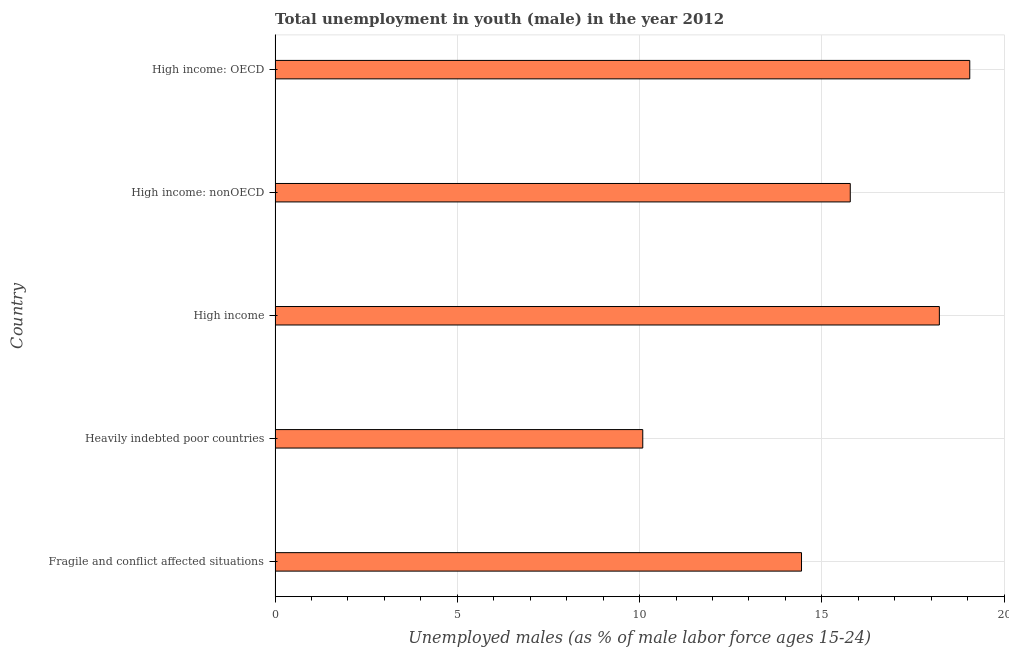Does the graph contain any zero values?
Keep it short and to the point. No. Does the graph contain grids?
Make the answer very short. Yes. What is the title of the graph?
Your answer should be compact. Total unemployment in youth (male) in the year 2012. What is the label or title of the X-axis?
Provide a short and direct response. Unemployed males (as % of male labor force ages 15-24). What is the unemployed male youth population in High income?
Give a very brief answer. 18.23. Across all countries, what is the maximum unemployed male youth population?
Provide a short and direct response. 19.06. Across all countries, what is the minimum unemployed male youth population?
Make the answer very short. 10.09. In which country was the unemployed male youth population maximum?
Give a very brief answer. High income: OECD. In which country was the unemployed male youth population minimum?
Offer a very short reply. Heavily indebted poor countries. What is the sum of the unemployed male youth population?
Provide a succinct answer. 77.6. What is the difference between the unemployed male youth population in Fragile and conflict affected situations and Heavily indebted poor countries?
Give a very brief answer. 4.36. What is the average unemployed male youth population per country?
Give a very brief answer. 15.52. What is the median unemployed male youth population?
Keep it short and to the point. 15.78. In how many countries, is the unemployed male youth population greater than 14 %?
Your answer should be compact. 4. What is the ratio of the unemployed male youth population in High income to that in High income: OECD?
Your answer should be compact. 0.96. Is the unemployed male youth population in High income: OECD less than that in High income: nonOECD?
Provide a short and direct response. No. What is the difference between the highest and the second highest unemployed male youth population?
Give a very brief answer. 0.83. What is the difference between the highest and the lowest unemployed male youth population?
Your response must be concise. 8.97. Are the values on the major ticks of X-axis written in scientific E-notation?
Offer a very short reply. No. What is the Unemployed males (as % of male labor force ages 15-24) in Fragile and conflict affected situations?
Provide a short and direct response. 14.44. What is the Unemployed males (as % of male labor force ages 15-24) of Heavily indebted poor countries?
Your answer should be compact. 10.09. What is the Unemployed males (as % of male labor force ages 15-24) in High income?
Ensure brevity in your answer.  18.23. What is the Unemployed males (as % of male labor force ages 15-24) of High income: nonOECD?
Ensure brevity in your answer.  15.78. What is the Unemployed males (as % of male labor force ages 15-24) of High income: OECD?
Offer a terse response. 19.06. What is the difference between the Unemployed males (as % of male labor force ages 15-24) in Fragile and conflict affected situations and Heavily indebted poor countries?
Offer a very short reply. 4.36. What is the difference between the Unemployed males (as % of male labor force ages 15-24) in Fragile and conflict affected situations and High income?
Your response must be concise. -3.78. What is the difference between the Unemployed males (as % of male labor force ages 15-24) in Fragile and conflict affected situations and High income: nonOECD?
Your answer should be very brief. -1.34. What is the difference between the Unemployed males (as % of male labor force ages 15-24) in Fragile and conflict affected situations and High income: OECD?
Your answer should be very brief. -4.62. What is the difference between the Unemployed males (as % of male labor force ages 15-24) in Heavily indebted poor countries and High income?
Your answer should be very brief. -8.14. What is the difference between the Unemployed males (as % of male labor force ages 15-24) in Heavily indebted poor countries and High income: nonOECD?
Give a very brief answer. -5.69. What is the difference between the Unemployed males (as % of male labor force ages 15-24) in Heavily indebted poor countries and High income: OECD?
Your answer should be compact. -8.97. What is the difference between the Unemployed males (as % of male labor force ages 15-24) in High income and High income: nonOECD?
Provide a short and direct response. 2.44. What is the difference between the Unemployed males (as % of male labor force ages 15-24) in High income and High income: OECD?
Make the answer very short. -0.83. What is the difference between the Unemployed males (as % of male labor force ages 15-24) in High income: nonOECD and High income: OECD?
Offer a very short reply. -3.28. What is the ratio of the Unemployed males (as % of male labor force ages 15-24) in Fragile and conflict affected situations to that in Heavily indebted poor countries?
Your response must be concise. 1.43. What is the ratio of the Unemployed males (as % of male labor force ages 15-24) in Fragile and conflict affected situations to that in High income?
Keep it short and to the point. 0.79. What is the ratio of the Unemployed males (as % of male labor force ages 15-24) in Fragile and conflict affected situations to that in High income: nonOECD?
Offer a very short reply. 0.92. What is the ratio of the Unemployed males (as % of male labor force ages 15-24) in Fragile and conflict affected situations to that in High income: OECD?
Your answer should be compact. 0.76. What is the ratio of the Unemployed males (as % of male labor force ages 15-24) in Heavily indebted poor countries to that in High income?
Keep it short and to the point. 0.55. What is the ratio of the Unemployed males (as % of male labor force ages 15-24) in Heavily indebted poor countries to that in High income: nonOECD?
Your answer should be compact. 0.64. What is the ratio of the Unemployed males (as % of male labor force ages 15-24) in Heavily indebted poor countries to that in High income: OECD?
Your response must be concise. 0.53. What is the ratio of the Unemployed males (as % of male labor force ages 15-24) in High income to that in High income: nonOECD?
Offer a terse response. 1.16. What is the ratio of the Unemployed males (as % of male labor force ages 15-24) in High income to that in High income: OECD?
Offer a very short reply. 0.96. What is the ratio of the Unemployed males (as % of male labor force ages 15-24) in High income: nonOECD to that in High income: OECD?
Your answer should be compact. 0.83. 